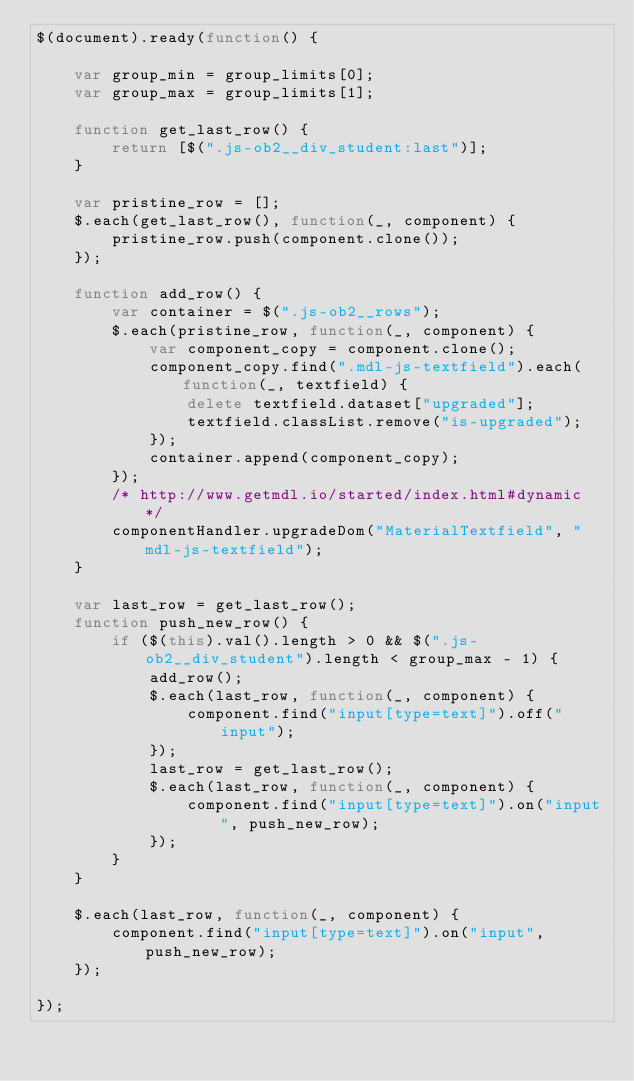<code> <loc_0><loc_0><loc_500><loc_500><_JavaScript_>$(document).ready(function() {

    var group_min = group_limits[0];
    var group_max = group_limits[1];

    function get_last_row() {
        return [$(".js-ob2__div_student:last")];
    }

    var pristine_row = [];
    $.each(get_last_row(), function(_, component) {
        pristine_row.push(component.clone());
    });

    function add_row() {
        var container = $(".js-ob2__rows");
        $.each(pristine_row, function(_, component) {
            var component_copy = component.clone();
            component_copy.find(".mdl-js-textfield").each(function(_, textfield) {
                delete textfield.dataset["upgraded"];
                textfield.classList.remove("is-upgraded");
            });
            container.append(component_copy);
        });
        /* http://www.getmdl.io/started/index.html#dynamic */
        componentHandler.upgradeDom("MaterialTextfield", "mdl-js-textfield");
    }

    var last_row = get_last_row();
    function push_new_row() {
        if ($(this).val().length > 0 && $(".js-ob2__div_student").length < group_max - 1) {
            add_row();
            $.each(last_row, function(_, component) {
                component.find("input[type=text]").off("input");
            });
            last_row = get_last_row();
            $.each(last_row, function(_, component) {
                component.find("input[type=text]").on("input", push_new_row);
            });
        }
    }

    $.each(last_row, function(_, component) {
        component.find("input[type=text]").on("input", push_new_row);
    });

});
</code> 